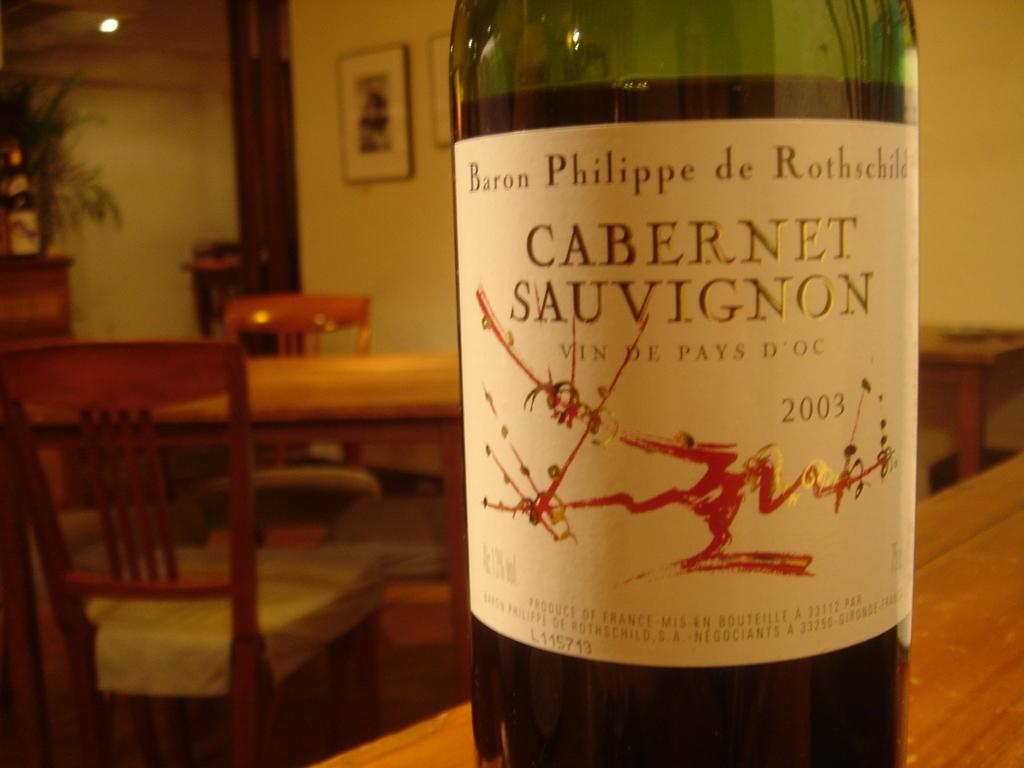What type of furniture is visible in the image? There are tables and chairs in the image. What might be used for displaying photos or artwork in the image? There are photo frames on the top of something, likely a table or shelf, in the image. What type of vegetation is on the left side of the image? There are plants on the left side of the image. What is used for illumination in the image? There are lights on the top of the image. What is present on a table in the image? A bottle is present on a table in the image. What color is the bottle in the image? The bottle is green in color. How many tomatoes are on the table in the image? There are no tomatoes present in the image. What type of blood is visible on the chair in the image? There is no blood visible in the image; it is not mentioned in the provided facts. 